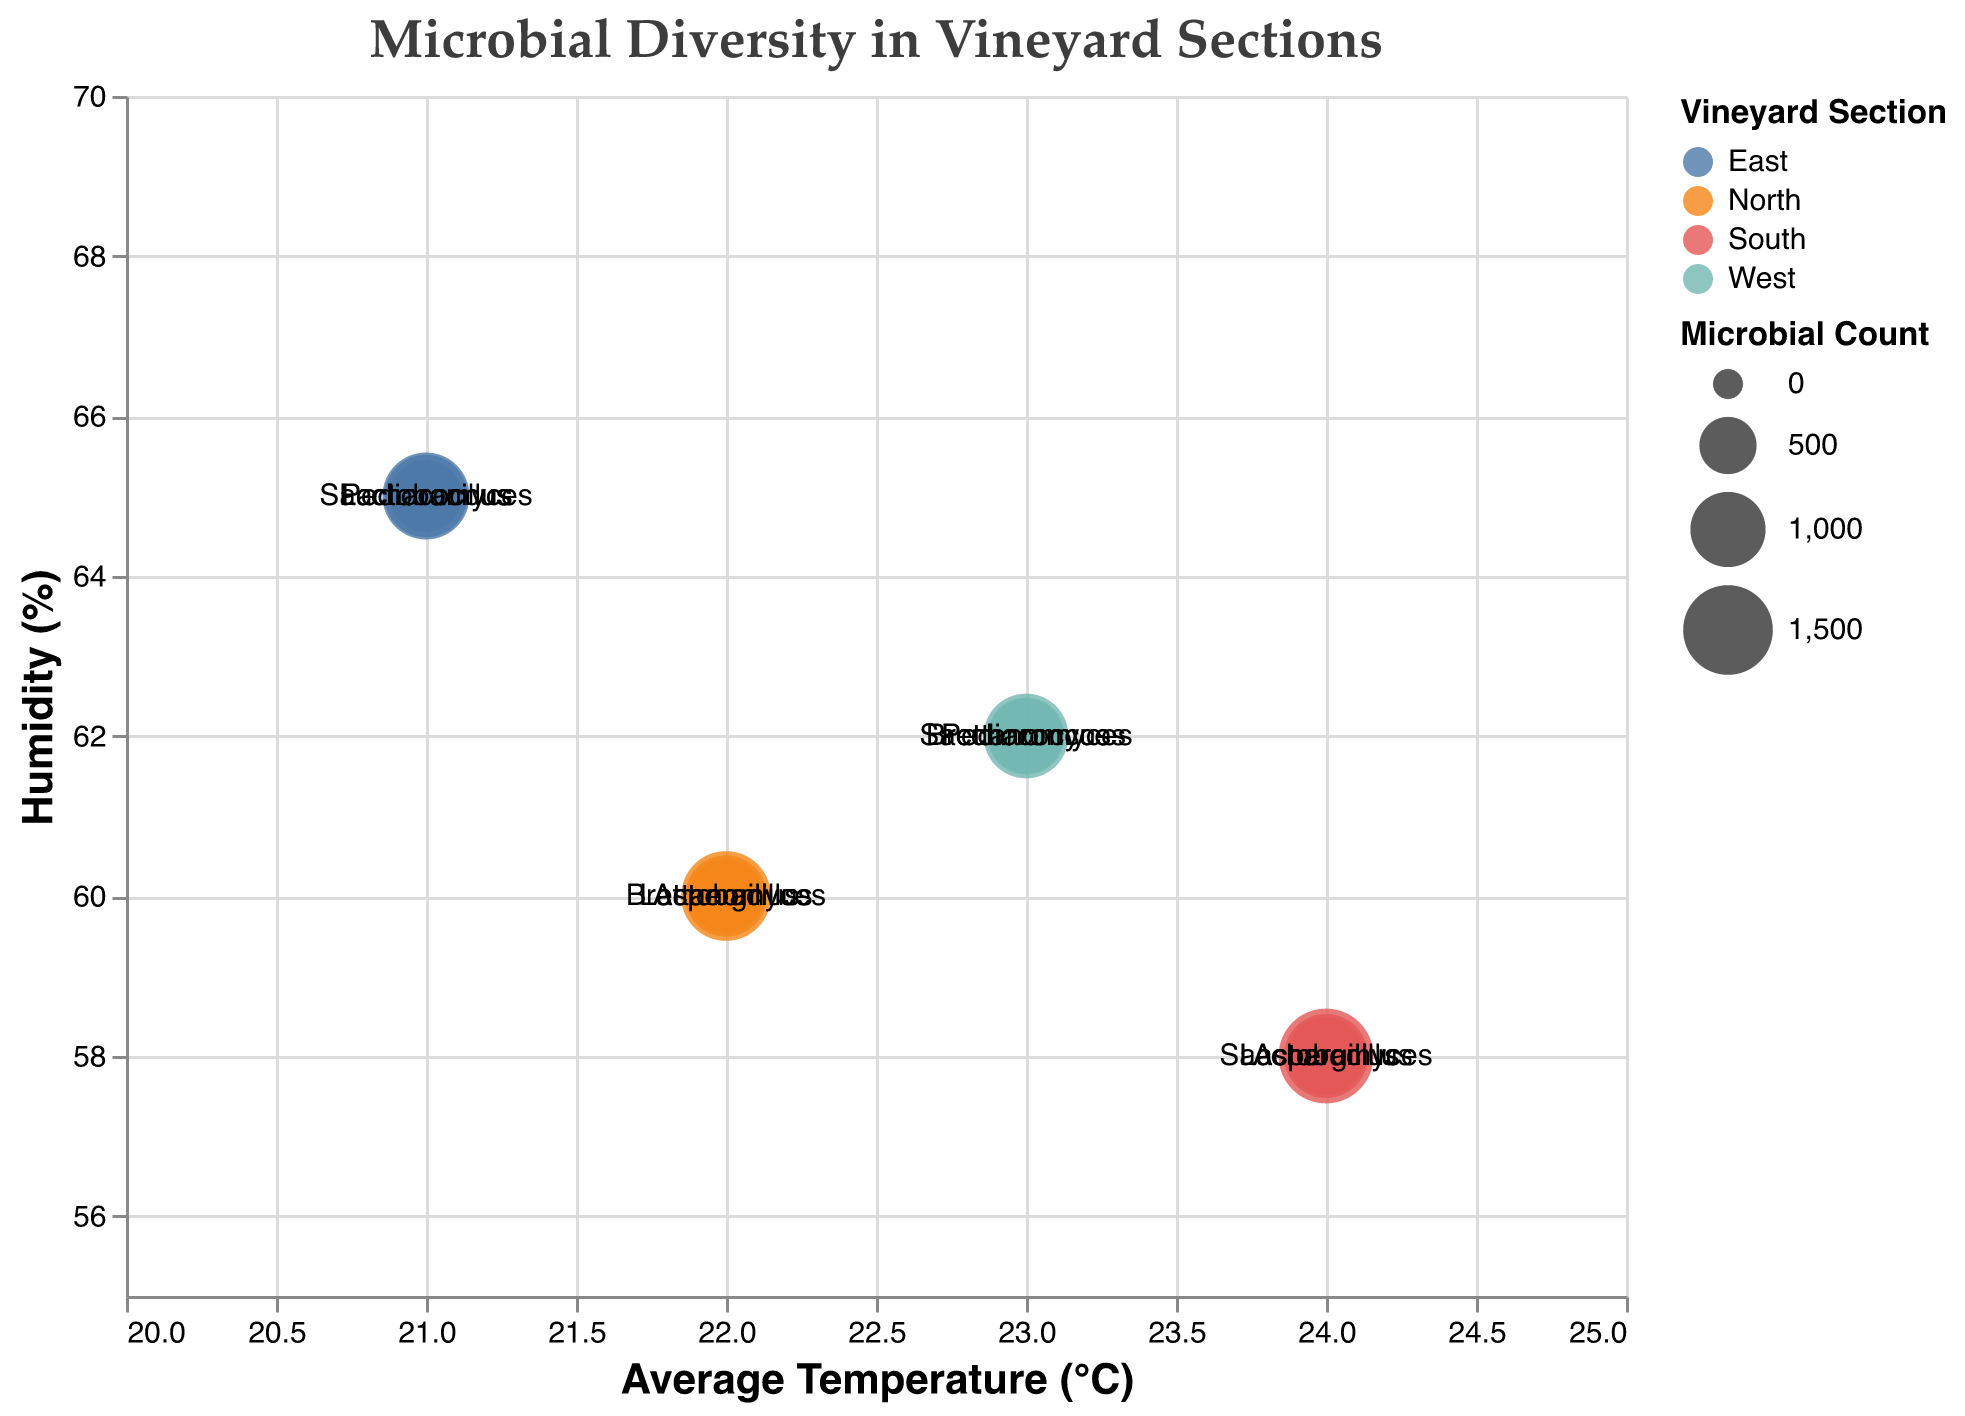How many sections does the vineyard have? Observing the color legend of the figure, we see different colors representing the vineyard sections. By counting these colors, we see there are North, South, East, and West sections.
Answer: 4 Which microbial species has the highest count in the South section? We locate the South section (identified by its color in the legend). The largest bubble size represents the highest microbial count, which is associated with "Aspergillus" at 1700.
Answer: Aspergillus What is the average microbial count of Lactobacillus across all sections? Sum the Lactobacillus counts from North, South, and East sections (1200 + 1100 + 1250) and divide by the number of sections (3). This calculation gives us the average: (1200 + 1100 + 1250) / 3 = 1183.33.
Answer: 1183.33 Between North and West sections, which one has a lower average humidity? Observing the y-axis values for points in North and West sections, North has a humidity of 60%, and West has a humidity of 62%. North has the lower average humidity.
Answer: North Which section has the smallest bubble size for Brettanomyces? Locate the Brettanomyces circles in the North and West sections. The North section has a count of 950, and the West section has a count of 1050. The smaller bubble (950) is in the North section.
Answer: North How does the humidity level in the East section compare to other sections? Observing the y-axis values for the East section (humidity at 65%), compare this to North (60%), South (58%), and West (62%). The East section has the highest humidity level among all sections.
Answer: Highest Which section has the most diverse range of microbial species? Identify the number of distinct species in each section. North has Aspergillus, Brettanomyces, and Lactobacillus (3 species); South has Aspergillus, Saccharomyces, and Lactobacillus (3 species); East has Saccharomyces, Pediococcus, and Lactobacillus (3 species); West has Brettanomyces, Pediococcus, and Saccharomyces (3 species). All sections have the same number of various species (3).
Answer: Equal (all sections) What is the temperature range across all sections represented in the chart? Observing the x-axis values from the lowest to the highest, the temperatures range from 21°C (East) to 24°C (South). This gives us the complete range from 21°C to 24°C.
Answer: 21°C to 24°C Which microbial species appears exclusively in the South section? By identifying all microbial species in the South section and comparing them with the rest, we note that "Saccharomyces" appears in both South and West sections. Therefore, the answer is none.
Answer: None 